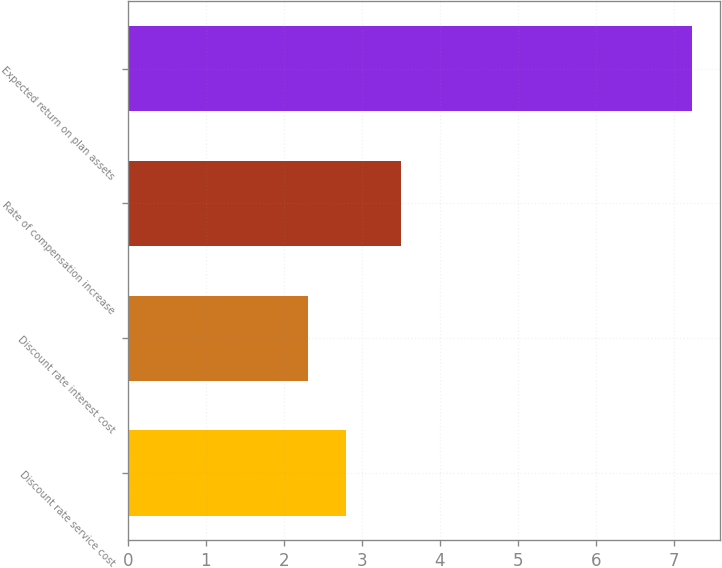Convert chart to OTSL. <chart><loc_0><loc_0><loc_500><loc_500><bar_chart><fcel>Discount rate service cost<fcel>Discount rate interest cost<fcel>Rate of compensation increase<fcel>Expected return on plan assets<nl><fcel>2.8<fcel>2.31<fcel>3.5<fcel>7.23<nl></chart> 